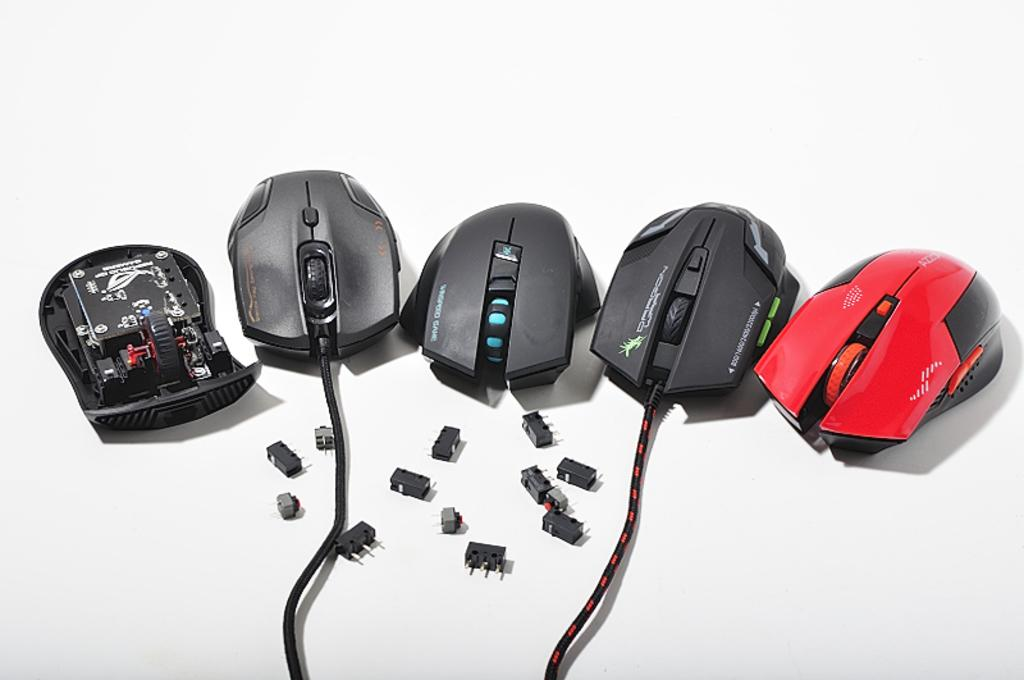What type of animals are present in the image? There are mice in the image. Where are the mice located? The mice are placed on a surface. What other objects can be seen in the image? There are switch buttons in the image. Can you tell me how many drains are visible in the image? There are no drains present in the image; it features mice on a surface and switch buttons. What type of large cat can be seen interacting with the mice in the image? There is no large cat, such as a tiger, present in the image; it only features mice and switch buttons. 